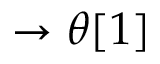Convert formula to latex. <formula><loc_0><loc_0><loc_500><loc_500>\rightarrow \theta [ 1 ]</formula> 